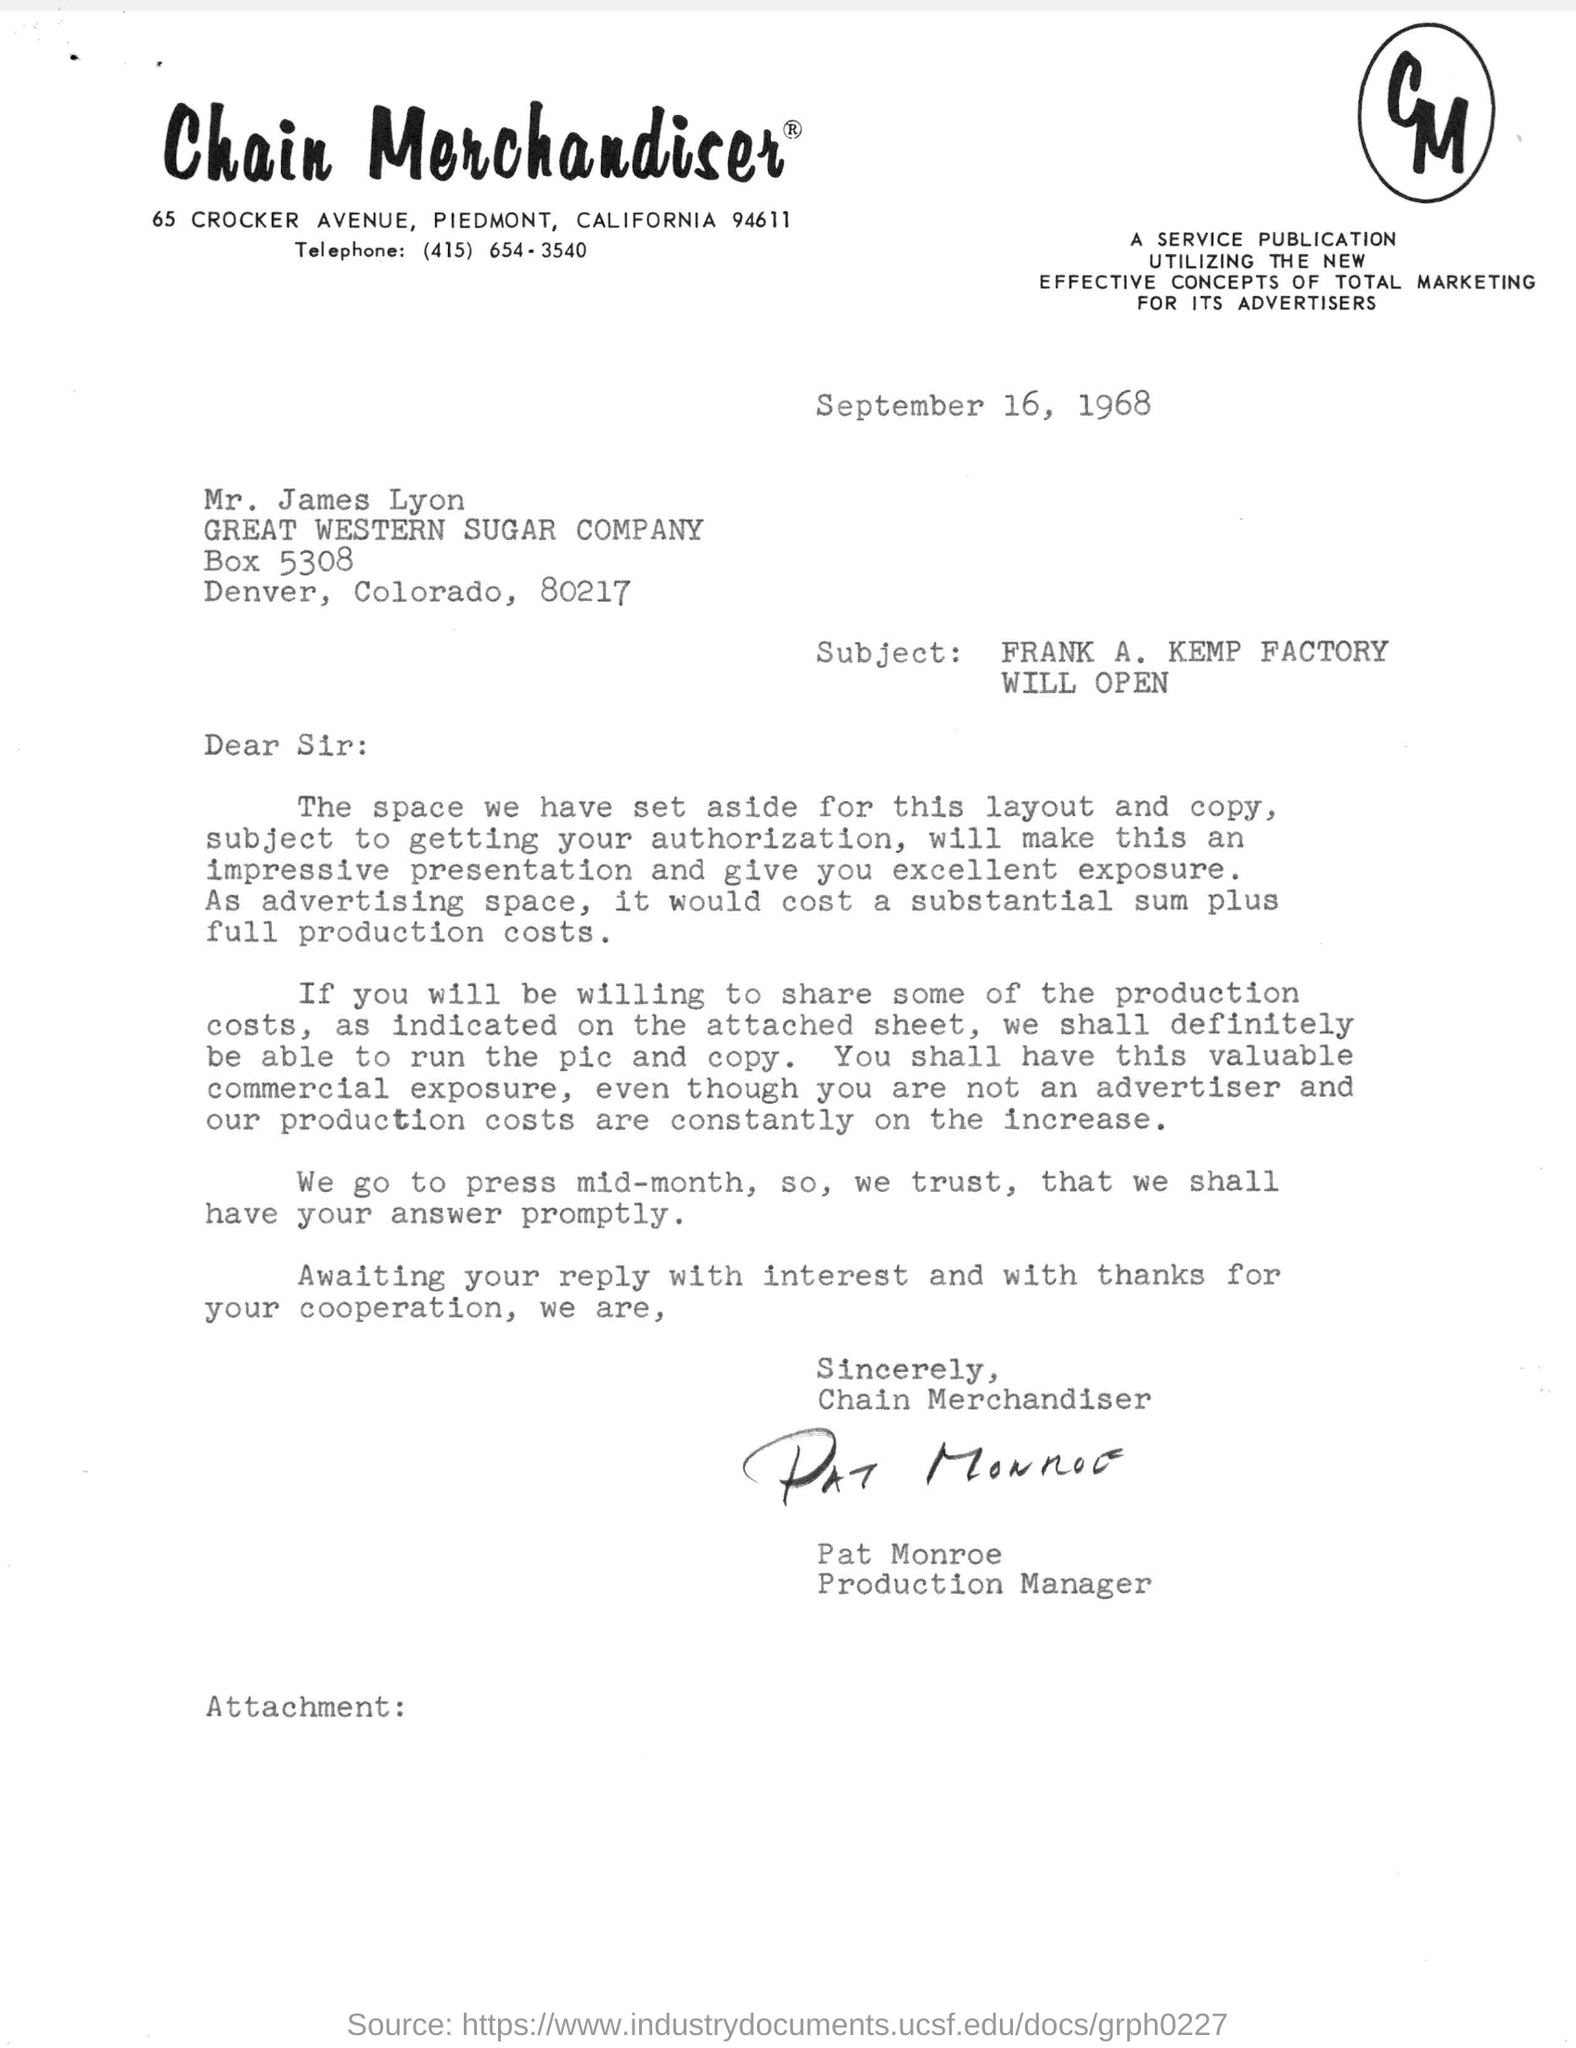Identify some key points in this picture. The subject of this letter is the announcement that the Frank A. Kemp factory will open. The telephone number mentioned in the letter is (415) 654-3540. The date mentioned in the letter is September 16, 1968. The letter has been signed by Pat Monroe. The letter is addressed to Mr. James Lyon. 